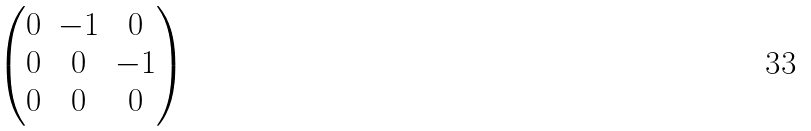<formula> <loc_0><loc_0><loc_500><loc_500>\begin{pmatrix} 0 & - 1 & 0 \\ 0 & 0 & - 1 \\ 0 & 0 & 0 \end{pmatrix}</formula> 